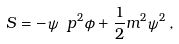<formula> <loc_0><loc_0><loc_500><loc_500>S = - \psi \ p ^ { 2 } \phi + \frac { 1 } { 2 } m ^ { 2 } \psi ^ { 2 } \, ,</formula> 